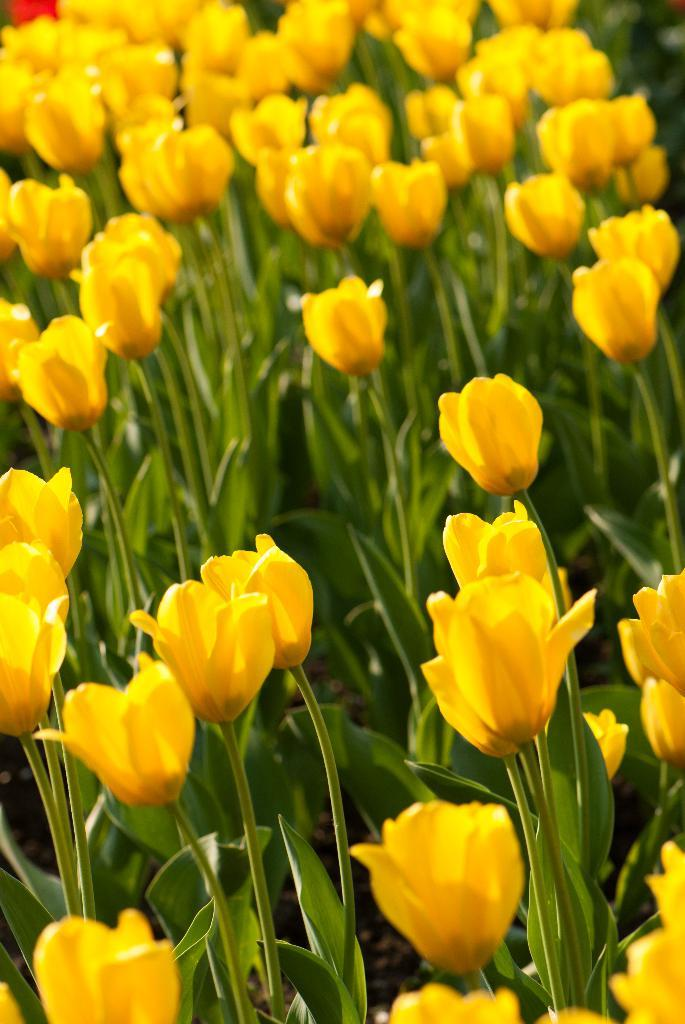What type of living organisms can be seen in the image? There are flowers and plants visible in the image. Can you describe the plants in the image? The plants in the image are not specified, but they are present alongside the flowers. How many oranges are hanging from the flowers in the image? There are no oranges present in the image; it features flowers and plants. What type of fowl can be seen interacting with the flowers in the image? There is no fowl present in the image; it only features flowers and plants. 